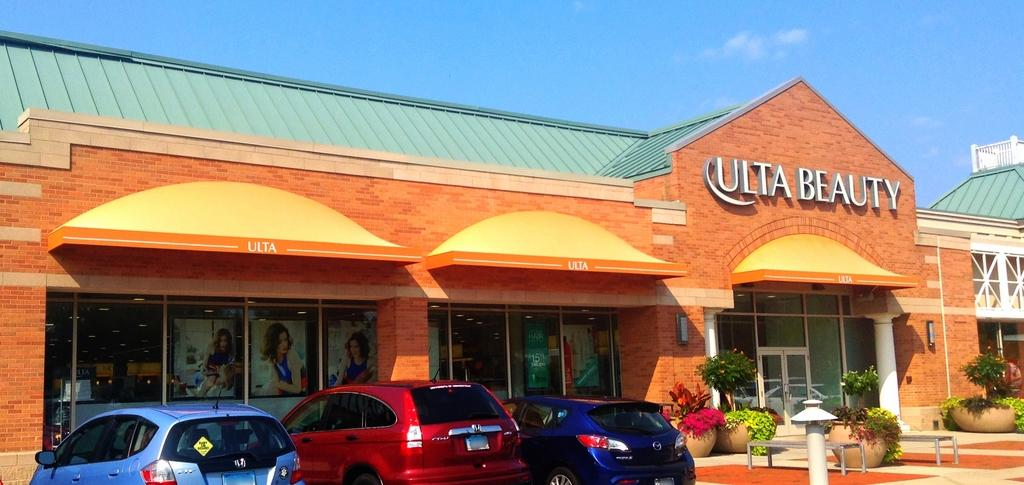What types of objects are present in the image? There are vehicles, house plants, and benches in the image. What is on the ground in the image? There is a pole on the ground in the image. What can be seen in the background of the image? There is a building and the sky visible in the background of the image. What type of grape is being used as an instrument in the image? There is no grape or instrument present in the image. 